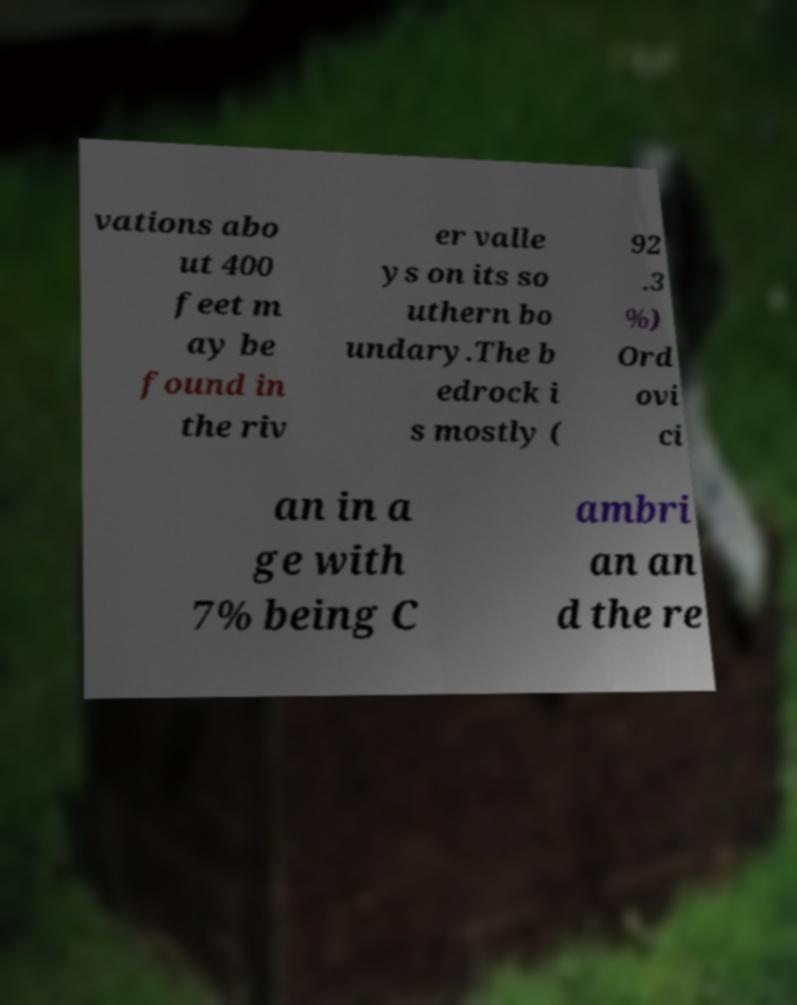Please identify and transcribe the text found in this image. vations abo ut 400 feet m ay be found in the riv er valle ys on its so uthern bo undary.The b edrock i s mostly ( 92 .3 %) Ord ovi ci an in a ge with 7% being C ambri an an d the re 